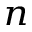<formula> <loc_0><loc_0><loc_500><loc_500>_ { n }</formula> 